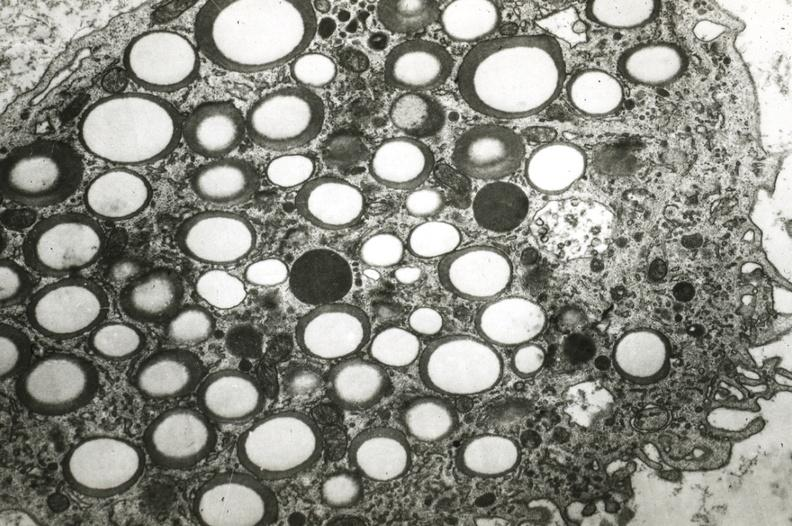what is present?
Answer the question using a single word or phrase. Cardiovascular 